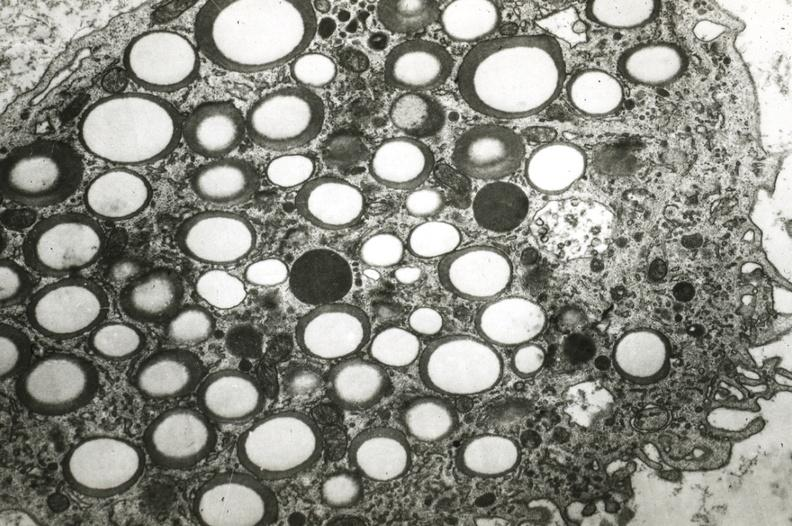what is present?
Answer the question using a single word or phrase. Cardiovascular 